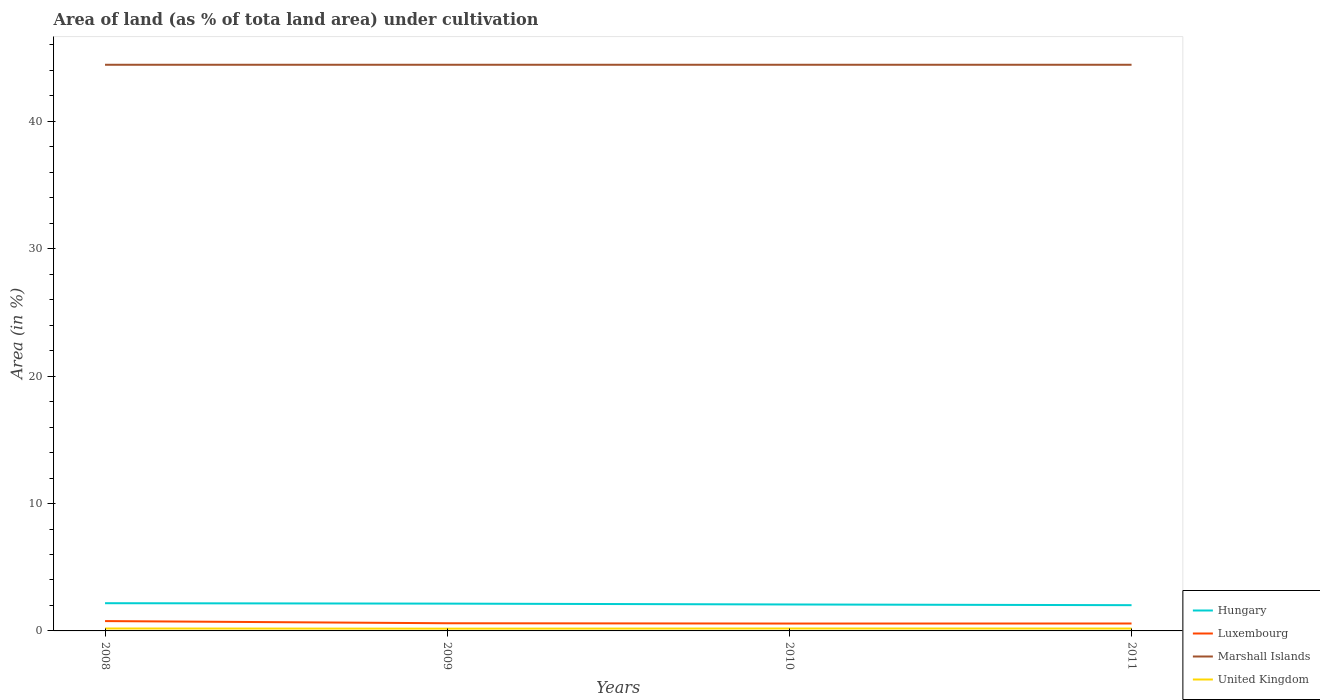How many different coloured lines are there?
Your response must be concise. 4. Does the line corresponding to Marshall Islands intersect with the line corresponding to Luxembourg?
Provide a succinct answer. No. Across all years, what is the maximum percentage of land under cultivation in United Kingdom?
Offer a terse response. 0.18. What is the total percentage of land under cultivation in Hungary in the graph?
Your response must be concise. 0.03. Is the percentage of land under cultivation in Luxembourg strictly greater than the percentage of land under cultivation in Hungary over the years?
Ensure brevity in your answer.  Yes. What is the difference between two consecutive major ticks on the Y-axis?
Keep it short and to the point. 10. Are the values on the major ticks of Y-axis written in scientific E-notation?
Give a very brief answer. No. Does the graph contain any zero values?
Make the answer very short. No. How many legend labels are there?
Your answer should be very brief. 4. How are the legend labels stacked?
Give a very brief answer. Vertical. What is the title of the graph?
Offer a terse response. Area of land (as % of tota land area) under cultivation. What is the label or title of the X-axis?
Offer a terse response. Years. What is the label or title of the Y-axis?
Ensure brevity in your answer.  Area (in %). What is the Area (in %) in Hungary in 2008?
Your answer should be very brief. 2.18. What is the Area (in %) of Luxembourg in 2008?
Offer a terse response. 0.77. What is the Area (in %) in Marshall Islands in 2008?
Offer a very short reply. 44.44. What is the Area (in %) in United Kingdom in 2008?
Ensure brevity in your answer.  0.19. What is the Area (in %) of Hungary in 2009?
Give a very brief answer. 2.14. What is the Area (in %) in Luxembourg in 2009?
Your response must be concise. 0.6. What is the Area (in %) in Marshall Islands in 2009?
Provide a short and direct response. 44.44. What is the Area (in %) of United Kingdom in 2009?
Provide a short and direct response. 0.18. What is the Area (in %) of Hungary in 2010?
Make the answer very short. 2.08. What is the Area (in %) of Luxembourg in 2010?
Your response must be concise. 0.58. What is the Area (in %) in Marshall Islands in 2010?
Your answer should be very brief. 44.44. What is the Area (in %) of United Kingdom in 2010?
Keep it short and to the point. 0.19. What is the Area (in %) of Hungary in 2011?
Your response must be concise. 2.02. What is the Area (in %) in Luxembourg in 2011?
Ensure brevity in your answer.  0.58. What is the Area (in %) in Marshall Islands in 2011?
Your answer should be compact. 44.44. What is the Area (in %) in United Kingdom in 2011?
Offer a terse response. 0.19. Across all years, what is the maximum Area (in %) in Hungary?
Provide a short and direct response. 2.18. Across all years, what is the maximum Area (in %) of Luxembourg?
Provide a succinct answer. 0.77. Across all years, what is the maximum Area (in %) of Marshall Islands?
Your response must be concise. 44.44. Across all years, what is the maximum Area (in %) in United Kingdom?
Ensure brevity in your answer.  0.19. Across all years, what is the minimum Area (in %) in Hungary?
Offer a terse response. 2.02. Across all years, what is the minimum Area (in %) of Luxembourg?
Your response must be concise. 0.58. Across all years, what is the minimum Area (in %) in Marshall Islands?
Your answer should be very brief. 44.44. Across all years, what is the minimum Area (in %) of United Kingdom?
Offer a terse response. 0.18. What is the total Area (in %) in Hungary in the graph?
Give a very brief answer. 8.42. What is the total Area (in %) in Luxembourg in the graph?
Make the answer very short. 2.54. What is the total Area (in %) in Marshall Islands in the graph?
Your answer should be very brief. 177.78. What is the total Area (in %) in United Kingdom in the graph?
Give a very brief answer. 0.74. What is the difference between the Area (in %) in Hungary in 2008 and that in 2009?
Your response must be concise. 0.03. What is the difference between the Area (in %) of Luxembourg in 2008 and that in 2009?
Ensure brevity in your answer.  0.17. What is the difference between the Area (in %) in United Kingdom in 2008 and that in 2009?
Ensure brevity in your answer.  0.01. What is the difference between the Area (in %) in Hungary in 2008 and that in 2010?
Your answer should be compact. 0.1. What is the difference between the Area (in %) in Luxembourg in 2008 and that in 2010?
Offer a terse response. 0.19. What is the difference between the Area (in %) in Marshall Islands in 2008 and that in 2010?
Provide a short and direct response. 0. What is the difference between the Area (in %) of Hungary in 2008 and that in 2011?
Your answer should be very brief. 0.15. What is the difference between the Area (in %) of Luxembourg in 2008 and that in 2011?
Your response must be concise. 0.19. What is the difference between the Area (in %) in United Kingdom in 2008 and that in 2011?
Ensure brevity in your answer.  0. What is the difference between the Area (in %) of Hungary in 2009 and that in 2010?
Make the answer very short. 0.07. What is the difference between the Area (in %) in Luxembourg in 2009 and that in 2010?
Keep it short and to the point. 0.02. What is the difference between the Area (in %) in Marshall Islands in 2009 and that in 2010?
Offer a terse response. 0. What is the difference between the Area (in %) in United Kingdom in 2009 and that in 2010?
Your answer should be very brief. -0.01. What is the difference between the Area (in %) in Hungary in 2009 and that in 2011?
Offer a very short reply. 0.12. What is the difference between the Area (in %) in Luxembourg in 2009 and that in 2011?
Provide a succinct answer. 0.02. What is the difference between the Area (in %) in Marshall Islands in 2009 and that in 2011?
Offer a terse response. 0. What is the difference between the Area (in %) in United Kingdom in 2009 and that in 2011?
Make the answer very short. -0.01. What is the difference between the Area (in %) in Hungary in 2010 and that in 2011?
Offer a very short reply. 0.06. What is the difference between the Area (in %) of Luxembourg in 2010 and that in 2011?
Provide a succinct answer. -0. What is the difference between the Area (in %) in United Kingdom in 2010 and that in 2011?
Your answer should be very brief. 0. What is the difference between the Area (in %) of Hungary in 2008 and the Area (in %) of Luxembourg in 2009?
Provide a succinct answer. 1.57. What is the difference between the Area (in %) in Hungary in 2008 and the Area (in %) in Marshall Islands in 2009?
Your response must be concise. -42.27. What is the difference between the Area (in %) of Hungary in 2008 and the Area (in %) of United Kingdom in 2009?
Keep it short and to the point. 2. What is the difference between the Area (in %) of Luxembourg in 2008 and the Area (in %) of Marshall Islands in 2009?
Give a very brief answer. -43.67. What is the difference between the Area (in %) of Luxembourg in 2008 and the Area (in %) of United Kingdom in 2009?
Keep it short and to the point. 0.59. What is the difference between the Area (in %) in Marshall Islands in 2008 and the Area (in %) in United Kingdom in 2009?
Give a very brief answer. 44.27. What is the difference between the Area (in %) of Hungary in 2008 and the Area (in %) of Luxembourg in 2010?
Offer a terse response. 1.6. What is the difference between the Area (in %) of Hungary in 2008 and the Area (in %) of Marshall Islands in 2010?
Make the answer very short. -42.27. What is the difference between the Area (in %) in Hungary in 2008 and the Area (in %) in United Kingdom in 2010?
Offer a very short reply. 1.99. What is the difference between the Area (in %) in Luxembourg in 2008 and the Area (in %) in Marshall Islands in 2010?
Offer a very short reply. -43.67. What is the difference between the Area (in %) of Luxembourg in 2008 and the Area (in %) of United Kingdom in 2010?
Your answer should be compact. 0.58. What is the difference between the Area (in %) in Marshall Islands in 2008 and the Area (in %) in United Kingdom in 2010?
Offer a very short reply. 44.25. What is the difference between the Area (in %) in Hungary in 2008 and the Area (in %) in Luxembourg in 2011?
Give a very brief answer. 1.59. What is the difference between the Area (in %) in Hungary in 2008 and the Area (in %) in Marshall Islands in 2011?
Your response must be concise. -42.27. What is the difference between the Area (in %) of Hungary in 2008 and the Area (in %) of United Kingdom in 2011?
Provide a short and direct response. 1.99. What is the difference between the Area (in %) in Luxembourg in 2008 and the Area (in %) in Marshall Islands in 2011?
Give a very brief answer. -43.67. What is the difference between the Area (in %) of Luxembourg in 2008 and the Area (in %) of United Kingdom in 2011?
Make the answer very short. 0.59. What is the difference between the Area (in %) in Marshall Islands in 2008 and the Area (in %) in United Kingdom in 2011?
Keep it short and to the point. 44.26. What is the difference between the Area (in %) in Hungary in 2009 and the Area (in %) in Luxembourg in 2010?
Your response must be concise. 1.56. What is the difference between the Area (in %) in Hungary in 2009 and the Area (in %) in Marshall Islands in 2010?
Give a very brief answer. -42.3. What is the difference between the Area (in %) of Hungary in 2009 and the Area (in %) of United Kingdom in 2010?
Your answer should be compact. 1.95. What is the difference between the Area (in %) in Luxembourg in 2009 and the Area (in %) in Marshall Islands in 2010?
Make the answer very short. -43.84. What is the difference between the Area (in %) in Luxembourg in 2009 and the Area (in %) in United Kingdom in 2010?
Offer a very short reply. 0.41. What is the difference between the Area (in %) in Marshall Islands in 2009 and the Area (in %) in United Kingdom in 2010?
Your answer should be compact. 44.25. What is the difference between the Area (in %) in Hungary in 2009 and the Area (in %) in Luxembourg in 2011?
Make the answer very short. 1.56. What is the difference between the Area (in %) of Hungary in 2009 and the Area (in %) of Marshall Islands in 2011?
Provide a short and direct response. -42.3. What is the difference between the Area (in %) in Hungary in 2009 and the Area (in %) in United Kingdom in 2011?
Keep it short and to the point. 1.96. What is the difference between the Area (in %) of Luxembourg in 2009 and the Area (in %) of Marshall Islands in 2011?
Your response must be concise. -43.84. What is the difference between the Area (in %) in Luxembourg in 2009 and the Area (in %) in United Kingdom in 2011?
Provide a short and direct response. 0.42. What is the difference between the Area (in %) in Marshall Islands in 2009 and the Area (in %) in United Kingdom in 2011?
Offer a very short reply. 44.26. What is the difference between the Area (in %) of Hungary in 2010 and the Area (in %) of Luxembourg in 2011?
Make the answer very short. 1.49. What is the difference between the Area (in %) of Hungary in 2010 and the Area (in %) of Marshall Islands in 2011?
Provide a short and direct response. -42.37. What is the difference between the Area (in %) in Hungary in 2010 and the Area (in %) in United Kingdom in 2011?
Provide a short and direct response. 1.89. What is the difference between the Area (in %) of Luxembourg in 2010 and the Area (in %) of Marshall Islands in 2011?
Provide a short and direct response. -43.87. What is the difference between the Area (in %) in Luxembourg in 2010 and the Area (in %) in United Kingdom in 2011?
Provide a succinct answer. 0.39. What is the difference between the Area (in %) in Marshall Islands in 2010 and the Area (in %) in United Kingdom in 2011?
Your response must be concise. 44.26. What is the average Area (in %) of Hungary per year?
Your answer should be compact. 2.1. What is the average Area (in %) of Luxembourg per year?
Provide a succinct answer. 0.63. What is the average Area (in %) in Marshall Islands per year?
Make the answer very short. 44.44. What is the average Area (in %) of United Kingdom per year?
Ensure brevity in your answer.  0.19. In the year 2008, what is the difference between the Area (in %) of Hungary and Area (in %) of Luxembourg?
Offer a terse response. 1.4. In the year 2008, what is the difference between the Area (in %) of Hungary and Area (in %) of Marshall Islands?
Your answer should be compact. -42.27. In the year 2008, what is the difference between the Area (in %) in Hungary and Area (in %) in United Kingdom?
Your answer should be very brief. 1.99. In the year 2008, what is the difference between the Area (in %) in Luxembourg and Area (in %) in Marshall Islands?
Make the answer very short. -43.67. In the year 2008, what is the difference between the Area (in %) of Luxembourg and Area (in %) of United Kingdom?
Give a very brief answer. 0.58. In the year 2008, what is the difference between the Area (in %) in Marshall Islands and Area (in %) in United Kingdom?
Your answer should be very brief. 44.25. In the year 2009, what is the difference between the Area (in %) of Hungary and Area (in %) of Luxembourg?
Ensure brevity in your answer.  1.54. In the year 2009, what is the difference between the Area (in %) of Hungary and Area (in %) of Marshall Islands?
Make the answer very short. -42.3. In the year 2009, what is the difference between the Area (in %) of Hungary and Area (in %) of United Kingdom?
Ensure brevity in your answer.  1.97. In the year 2009, what is the difference between the Area (in %) of Luxembourg and Area (in %) of Marshall Islands?
Make the answer very short. -43.84. In the year 2009, what is the difference between the Area (in %) in Luxembourg and Area (in %) in United Kingdom?
Offer a terse response. 0.42. In the year 2009, what is the difference between the Area (in %) of Marshall Islands and Area (in %) of United Kingdom?
Offer a terse response. 44.27. In the year 2010, what is the difference between the Area (in %) of Hungary and Area (in %) of Luxembourg?
Keep it short and to the point. 1.5. In the year 2010, what is the difference between the Area (in %) of Hungary and Area (in %) of Marshall Islands?
Provide a succinct answer. -42.37. In the year 2010, what is the difference between the Area (in %) of Hungary and Area (in %) of United Kingdom?
Offer a very short reply. 1.89. In the year 2010, what is the difference between the Area (in %) of Luxembourg and Area (in %) of Marshall Islands?
Your answer should be very brief. -43.87. In the year 2010, what is the difference between the Area (in %) in Luxembourg and Area (in %) in United Kingdom?
Provide a short and direct response. 0.39. In the year 2010, what is the difference between the Area (in %) in Marshall Islands and Area (in %) in United Kingdom?
Offer a terse response. 44.25. In the year 2011, what is the difference between the Area (in %) of Hungary and Area (in %) of Luxembourg?
Ensure brevity in your answer.  1.44. In the year 2011, what is the difference between the Area (in %) in Hungary and Area (in %) in Marshall Islands?
Keep it short and to the point. -42.42. In the year 2011, what is the difference between the Area (in %) of Hungary and Area (in %) of United Kingdom?
Give a very brief answer. 1.84. In the year 2011, what is the difference between the Area (in %) of Luxembourg and Area (in %) of Marshall Islands?
Make the answer very short. -43.86. In the year 2011, what is the difference between the Area (in %) of Luxembourg and Area (in %) of United Kingdom?
Your response must be concise. 0.4. In the year 2011, what is the difference between the Area (in %) in Marshall Islands and Area (in %) in United Kingdom?
Offer a very short reply. 44.26. What is the ratio of the Area (in %) of Hungary in 2008 to that in 2009?
Your response must be concise. 1.02. What is the ratio of the Area (in %) in Luxembourg in 2008 to that in 2009?
Give a very brief answer. 1.28. What is the ratio of the Area (in %) of United Kingdom in 2008 to that in 2009?
Ensure brevity in your answer.  1.07. What is the ratio of the Area (in %) of Hungary in 2008 to that in 2010?
Provide a succinct answer. 1.05. What is the ratio of the Area (in %) of United Kingdom in 2008 to that in 2010?
Offer a terse response. 1. What is the ratio of the Area (in %) in Hungary in 2008 to that in 2011?
Your answer should be very brief. 1.08. What is the ratio of the Area (in %) in Luxembourg in 2008 to that in 2011?
Keep it short and to the point. 1.32. What is the ratio of the Area (in %) in United Kingdom in 2008 to that in 2011?
Offer a very short reply. 1.02. What is the ratio of the Area (in %) in Hungary in 2009 to that in 2010?
Your answer should be compact. 1.03. What is the ratio of the Area (in %) in Luxembourg in 2009 to that in 2010?
Keep it short and to the point. 1.04. What is the ratio of the Area (in %) in Marshall Islands in 2009 to that in 2010?
Keep it short and to the point. 1. What is the ratio of the Area (in %) of United Kingdom in 2009 to that in 2010?
Keep it short and to the point. 0.93. What is the ratio of the Area (in %) in Hungary in 2009 to that in 2011?
Offer a terse response. 1.06. What is the ratio of the Area (in %) in Luxembourg in 2009 to that in 2011?
Keep it short and to the point. 1.03. What is the ratio of the Area (in %) of Marshall Islands in 2009 to that in 2011?
Your answer should be compact. 1. What is the ratio of the Area (in %) in United Kingdom in 2009 to that in 2011?
Provide a succinct answer. 0.96. What is the ratio of the Area (in %) of Hungary in 2010 to that in 2011?
Offer a very short reply. 1.03. What is the ratio of the Area (in %) of United Kingdom in 2010 to that in 2011?
Provide a succinct answer. 1.02. What is the difference between the highest and the second highest Area (in %) of Hungary?
Give a very brief answer. 0.03. What is the difference between the highest and the second highest Area (in %) of Luxembourg?
Your answer should be very brief. 0.17. What is the difference between the highest and the second highest Area (in %) in Marshall Islands?
Make the answer very short. 0. What is the difference between the highest and the second highest Area (in %) in United Kingdom?
Your response must be concise. 0. What is the difference between the highest and the lowest Area (in %) of Hungary?
Offer a very short reply. 0.15. What is the difference between the highest and the lowest Area (in %) of Luxembourg?
Your response must be concise. 0.19. What is the difference between the highest and the lowest Area (in %) in Marshall Islands?
Your answer should be very brief. 0. What is the difference between the highest and the lowest Area (in %) of United Kingdom?
Offer a terse response. 0.01. 